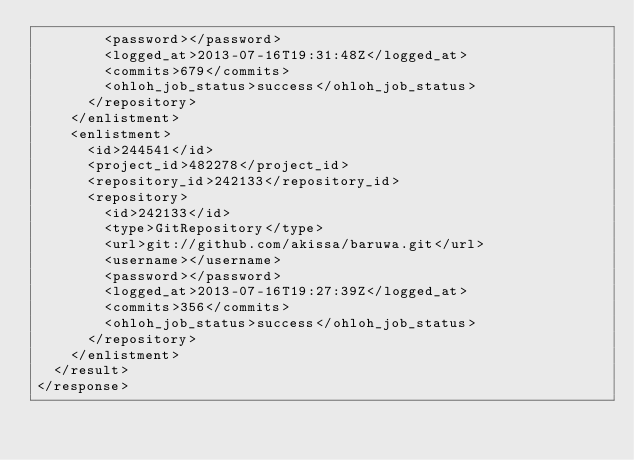<code> <loc_0><loc_0><loc_500><loc_500><_XML_>        <password></password>
        <logged_at>2013-07-16T19:31:48Z</logged_at>
        <commits>679</commits>
        <ohloh_job_status>success</ohloh_job_status>
      </repository>
    </enlistment>
    <enlistment>
      <id>244541</id>
      <project_id>482278</project_id>
      <repository_id>242133</repository_id>
      <repository>
        <id>242133</id>
        <type>GitRepository</type>
        <url>git://github.com/akissa/baruwa.git</url>
        <username></username>
        <password></password>
        <logged_at>2013-07-16T19:27:39Z</logged_at>
        <commits>356</commits>
        <ohloh_job_status>success</ohloh_job_status>
      </repository>
    </enlistment>
  </result>
</response>
</code> 